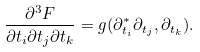Convert formula to latex. <formula><loc_0><loc_0><loc_500><loc_500>\frac { \partial ^ { 3 } F } { \partial t _ { i } \partial t _ { j } \partial t _ { k } } = g ( \partial _ { t _ { i } } ^ { * } \partial _ { t _ { j } } , \partial _ { t _ { k } } ) .</formula> 